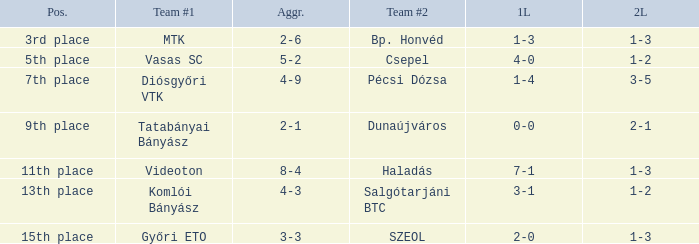What position has a 2-6 agg.? 3rd place. 